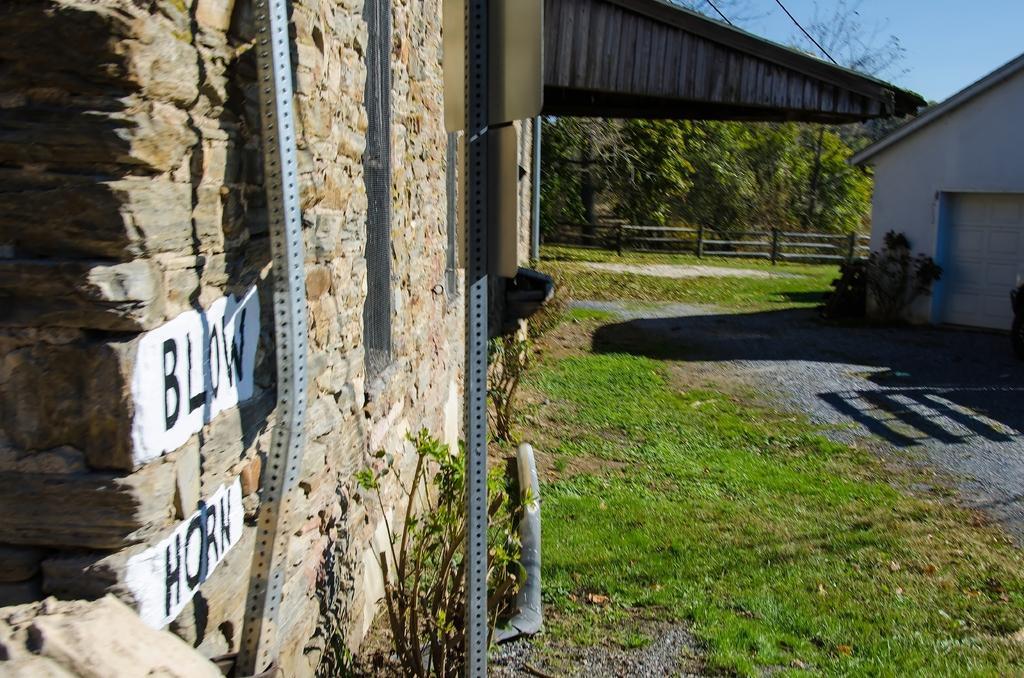How would you summarize this image in a sentence or two? In this image we can see some text on a wall. We can also see the metal poles, grass, plants, a house, fence, a group of trees and the sky. 